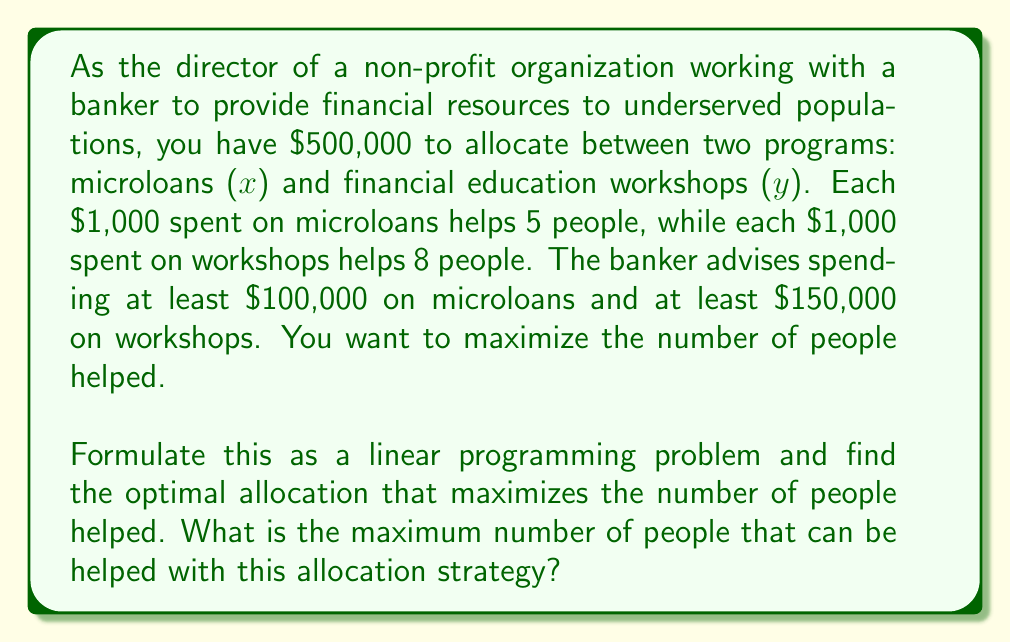Help me with this question. Let's approach this step-by-step:

1) Define variables:
   $x$ = amount spent on microloans (in thousands of dollars)
   $y$ = amount spent on workshops (in thousands of dollars)

2) Objective function:
   We want to maximize the number of people helped.
   Maximize $Z = 5x + 8y$

3) Constraints:
   - Total budget: $x + y \leq 500$
   - Minimum spend on microloans: $x \geq 100$
   - Minimum spend on workshops: $y \geq 150$
   - Non-negativity: $x \geq 0, y \geq 0$

4) The linear programming problem:
   Maximize $Z = 5x + 8y$
   Subject to:
   $$\begin{aligned}
   x + y &\leq 500 \\
   x &\geq 100 \\
   y &\geq 150 \\
   x, y &\geq 0
   \end{aligned}$$

5) To solve this, we can use the corner point method. The feasible region is a polygon defined by these constraints. The optimal solution will be at one of the corners of this polygon.

6) The corners of the feasible region are:
   (100, 150), (100, 400), (350, 150)

7) Evaluate Z at each corner:
   - At (100, 150): $Z = 5(100) + 8(150) = 1700$
   - At (100, 400): $Z = 5(100) + 8(400) = 3700$
   - At (350, 150): $Z = 5(350) + 8(150) = 2950$

8) The maximum value of Z occurs at the point (100, 400).

Therefore, the optimal allocation is to spend $100,000 on microloans and $400,000 on workshops.
Answer: The maximum number of people that can be helped is 3,700. 